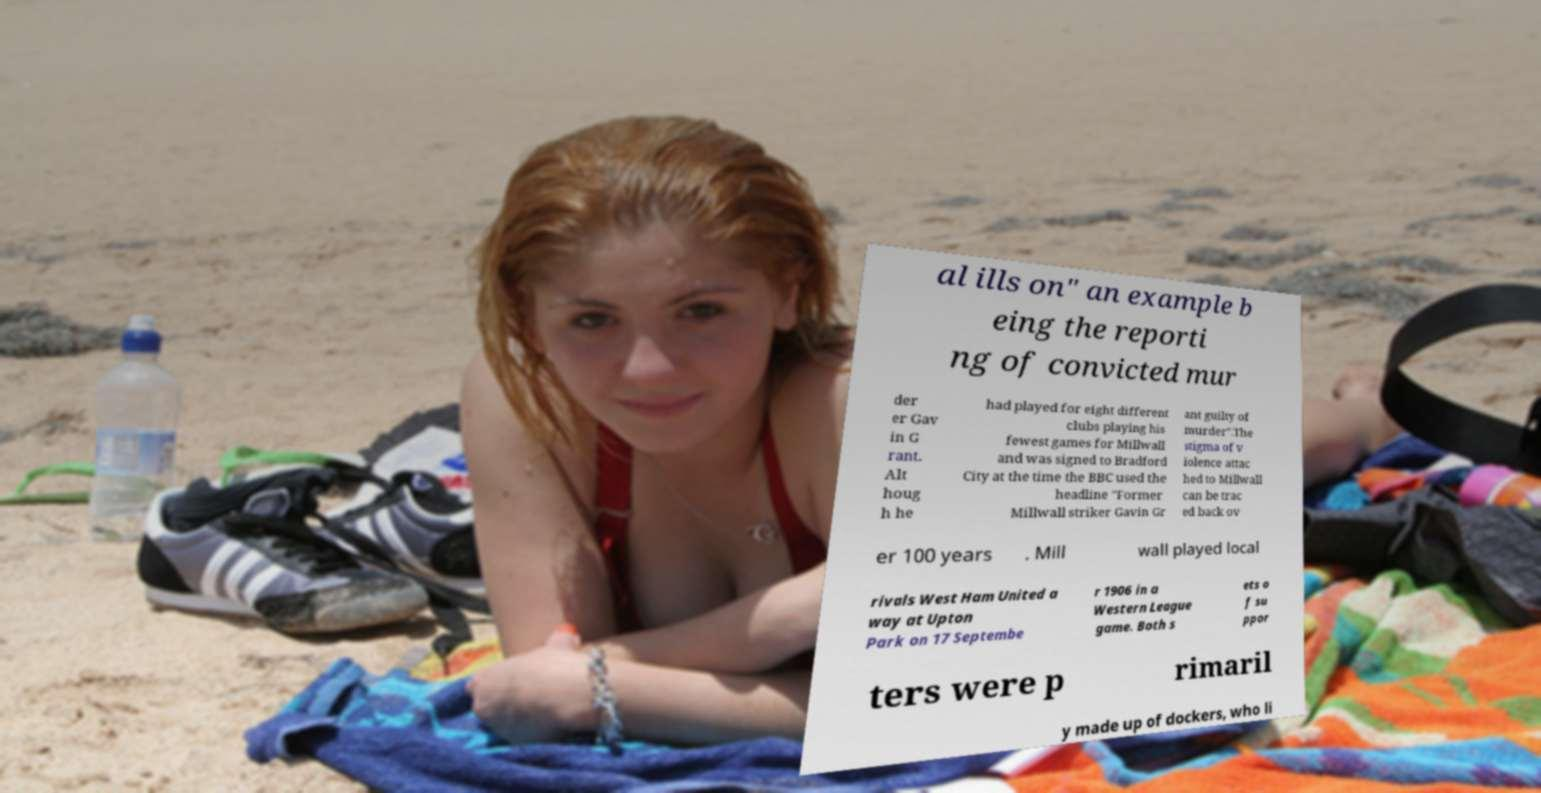There's text embedded in this image that I need extracted. Can you transcribe it verbatim? al ills on" an example b eing the reporti ng of convicted mur der er Gav in G rant. Alt houg h he had played for eight different clubs playing his fewest games for Millwall and was signed to Bradford City at the time the BBC used the headline "Former Millwall striker Gavin Gr ant guilty of murder".The stigma of v iolence attac hed to Millwall can be trac ed back ov er 100 years . Mill wall played local rivals West Ham United a way at Upton Park on 17 Septembe r 1906 in a Western League game. Both s ets o f su ppor ters were p rimaril y made up of dockers, who li 